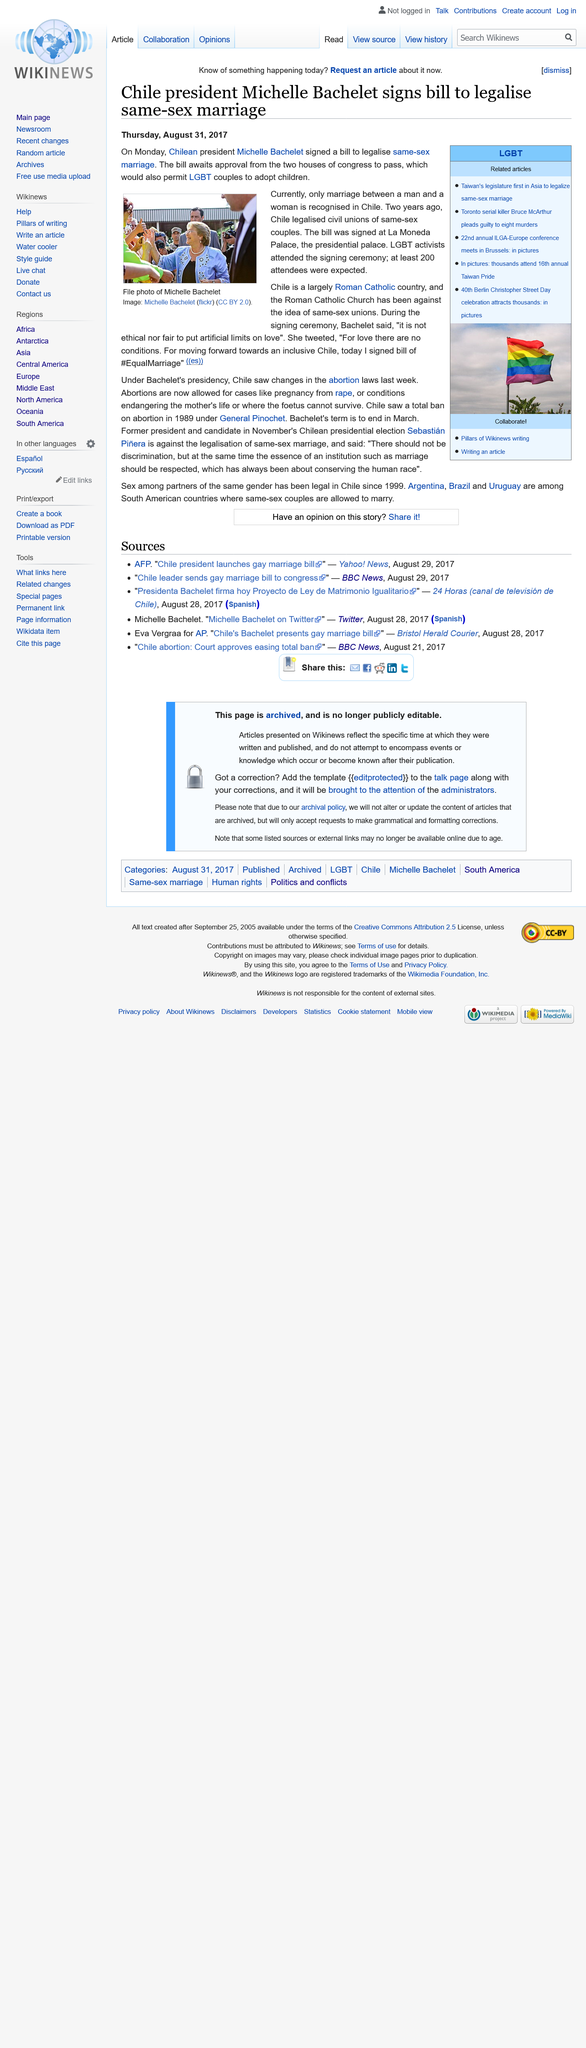Mention a couple of crucial points in this snapshot. This article about the legalization of same-sex marriage was written on Thursday, August 31, 2017. I hereby declare that the Chilean President, Michelle Bachelet, signed the bill on Monday, January 27th, 2023. The bill was signed at La Moneda Palace, where it was initially introduced. 